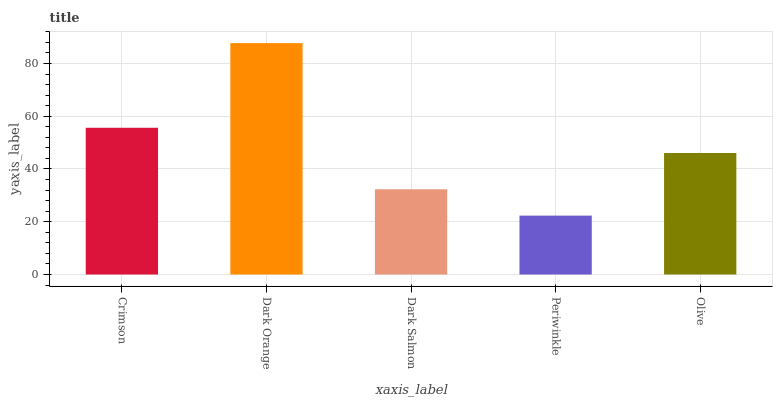Is Periwinkle the minimum?
Answer yes or no. Yes. Is Dark Orange the maximum?
Answer yes or no. Yes. Is Dark Salmon the minimum?
Answer yes or no. No. Is Dark Salmon the maximum?
Answer yes or no. No. Is Dark Orange greater than Dark Salmon?
Answer yes or no. Yes. Is Dark Salmon less than Dark Orange?
Answer yes or no. Yes. Is Dark Salmon greater than Dark Orange?
Answer yes or no. No. Is Dark Orange less than Dark Salmon?
Answer yes or no. No. Is Olive the high median?
Answer yes or no. Yes. Is Olive the low median?
Answer yes or no. Yes. Is Crimson the high median?
Answer yes or no. No. Is Dark Orange the low median?
Answer yes or no. No. 